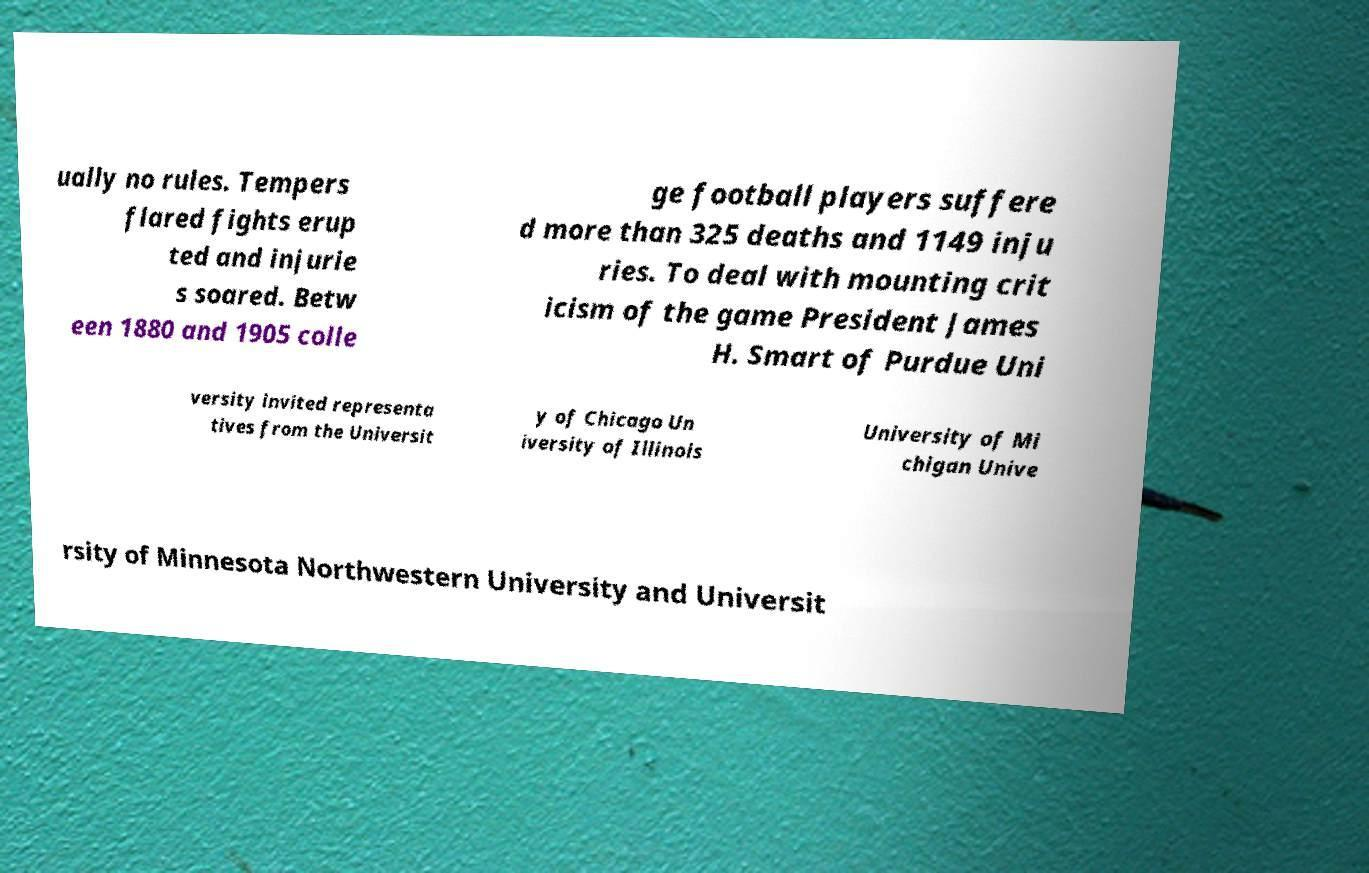There's text embedded in this image that I need extracted. Can you transcribe it verbatim? ually no rules. Tempers flared fights erup ted and injurie s soared. Betw een 1880 and 1905 colle ge football players suffere d more than 325 deaths and 1149 inju ries. To deal with mounting crit icism of the game President James H. Smart of Purdue Uni versity invited representa tives from the Universit y of Chicago Un iversity of Illinois University of Mi chigan Unive rsity of Minnesota Northwestern University and Universit 